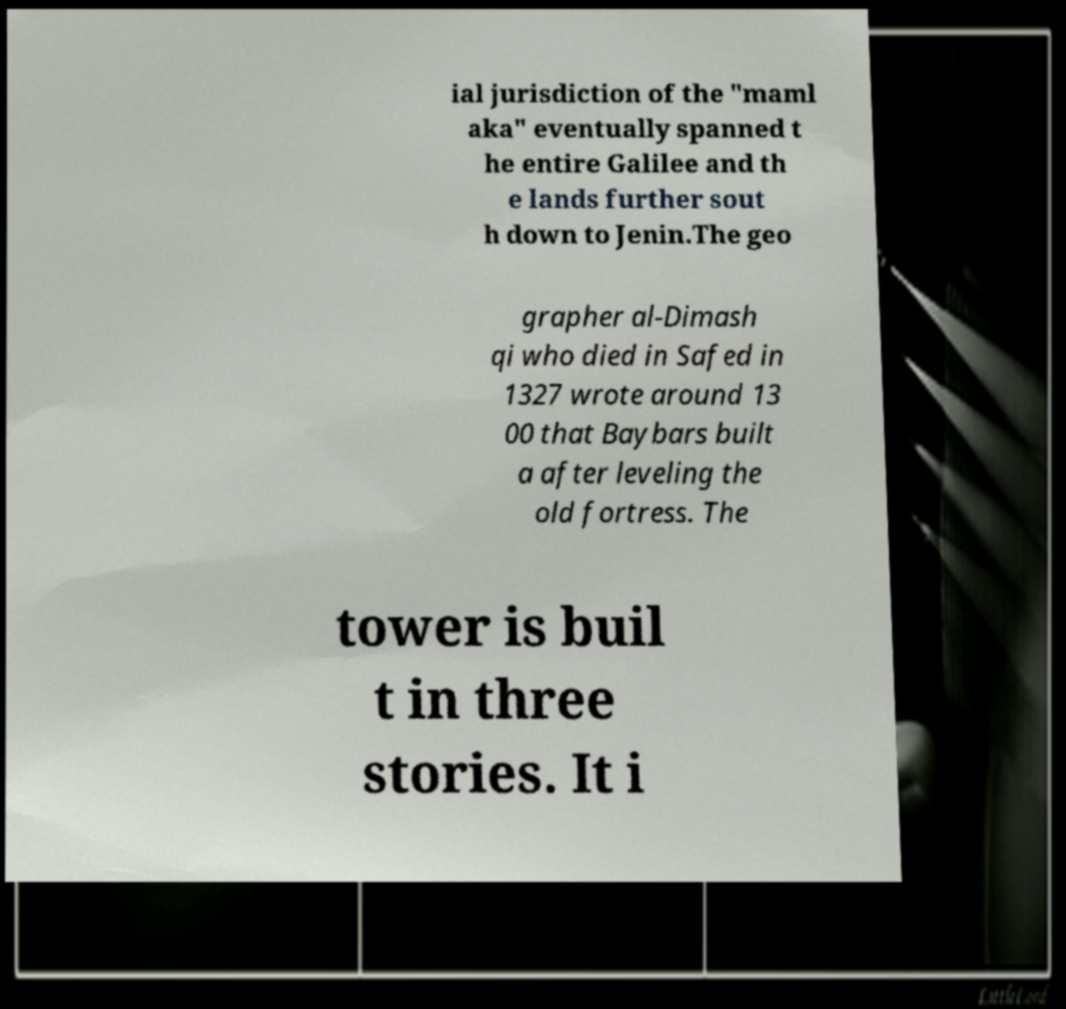Can you accurately transcribe the text from the provided image for me? ial jurisdiction of the "maml aka" eventually spanned t he entire Galilee and th e lands further sout h down to Jenin.The geo grapher al-Dimash qi who died in Safed in 1327 wrote around 13 00 that Baybars built a after leveling the old fortress. The tower is buil t in three stories. It i 